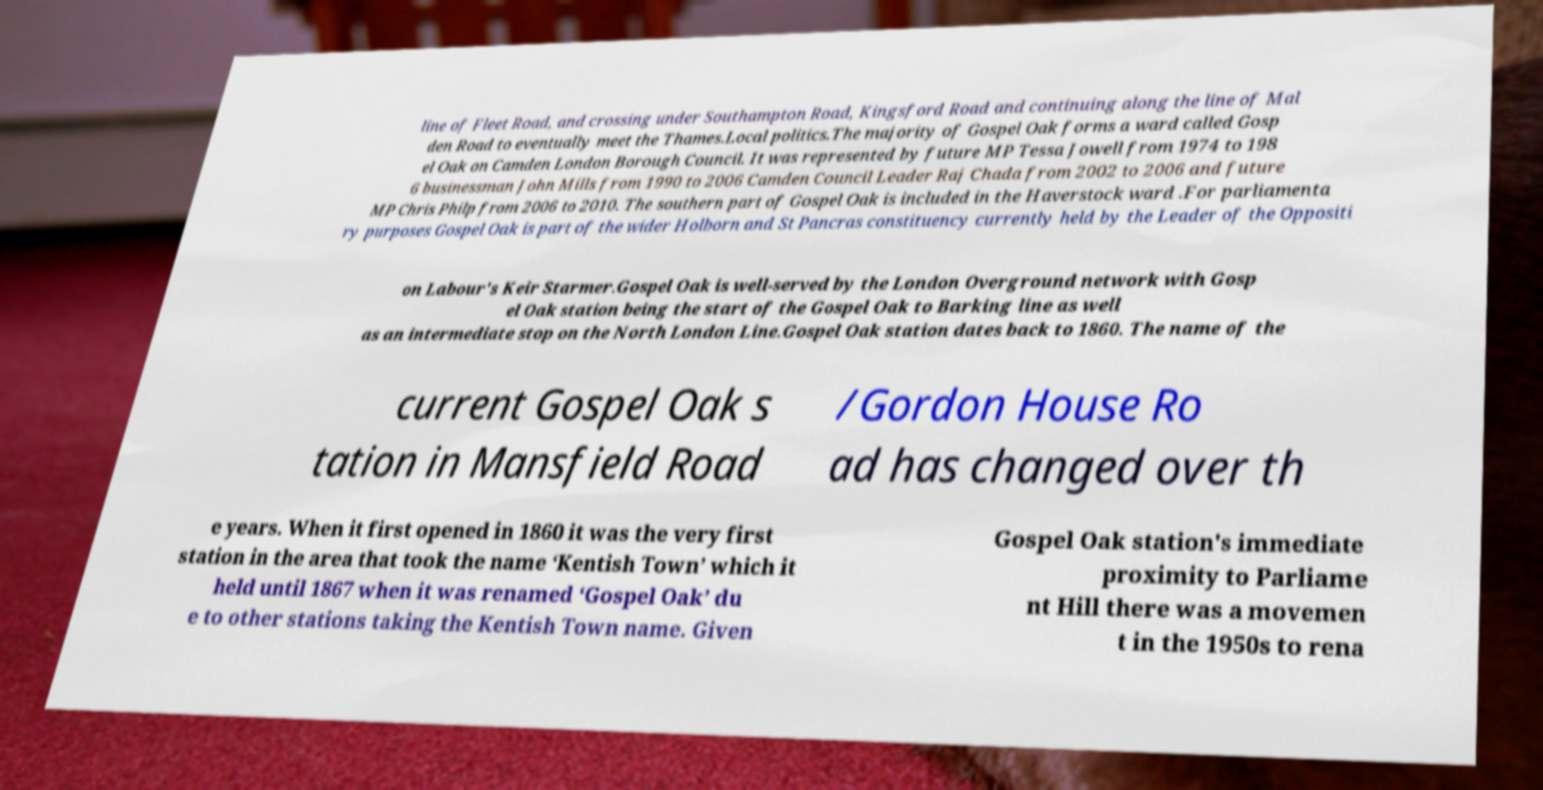Please read and relay the text visible in this image. What does it say? line of Fleet Road, and crossing under Southampton Road, Kingsford Road and continuing along the line of Mal den Road to eventually meet the Thames.Local politics.The majority of Gospel Oak forms a ward called Gosp el Oak on Camden London Borough Council. It was represented by future MP Tessa Jowell from 1974 to 198 6 businessman John Mills from 1990 to 2006 Camden Council Leader Raj Chada from 2002 to 2006 and future MP Chris Philp from 2006 to 2010. The southern part of Gospel Oak is included in the Haverstock ward .For parliamenta ry purposes Gospel Oak is part of the wider Holborn and St Pancras constituency currently held by the Leader of the Oppositi on Labour's Keir Starmer.Gospel Oak is well-served by the London Overground network with Gosp el Oak station being the start of the Gospel Oak to Barking line as well as an intermediate stop on the North London Line.Gospel Oak station dates back to 1860. The name of the current Gospel Oak s tation in Mansfield Road /Gordon House Ro ad has changed over th e years. When it first opened in 1860 it was the very first station in the area that took the name ‘Kentish Town’ which it held until 1867 when it was renamed ‘Gospel Oak’ du e to other stations taking the Kentish Town name. Given Gospel Oak station's immediate proximity to Parliame nt Hill there was a movemen t in the 1950s to rena 